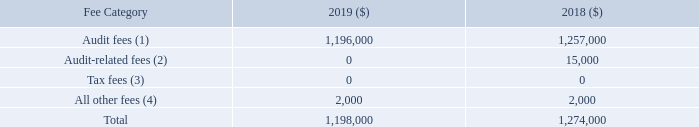Fees Paid to our Independent Auditor
The following table sets forth the fees billed to us by Ernst & Young LLP for services in fiscal 2019 and 2018, all of which
were pre-approved by the Audit Committee.
(1) In accordance with the SEC’s definitions and rules, “audit fees” are fees that were billed to Systemax by Ernst & Young LLP for
the audit of our annual financial statements, to be included in the Form 10-K, and review of financial statements included in the
Form 10-Qs; for the audit of our internal control over financial reporting with the objective of obtaining reasonable assurance about
whether effective internal control over financial reporting was maintained in all material respects; for the attestation of management’s
report on the effectiveness of internal control over financial reporting; and for services that are normally provided by the auditor
in connection with statutory and regulatory filings or engagements.
(2) “Audit-related fees” are fees for assurance and related services that are reasonably related to the performance of the audit or
review of our financial statements and internal control over financial reporting, including services in connection with assisting
Systemax in our compliance with our obligations under Section 404 of the Sarbanes-Oxley Act and related regulations.
(3) Ernst & Young LLP did not provide any professional services for tax compliance, planning or advice in 2019 or 2018.
(4) Consists of fees billed for other professional services rendered to Systemax.
What are the audit fees incurred by the company in 2018 and 2019? 1,257,000, 1,196,000. What does "all other fee" refer to? Fees billed for other professional services rendered to systemax. What are the all other fees incurred by the company in 2018 and 2019? 2,000, 2,000. What is the percentage change in all other fees incurred by the company between 2018 and 2019?
Answer scale should be: percent. (2,000 - 2,000)/2,000 
Answer: 0. What is the value of the audit-related fees as a percentage of the total fees paid to the auditor in 2018?
Answer scale should be: percent. 15,000/1,274,000 
Answer: 1.18. What is the change in audit fees between 2018 and 2019? 1,257,000 - 1,196,000 
Answer: 61000. 